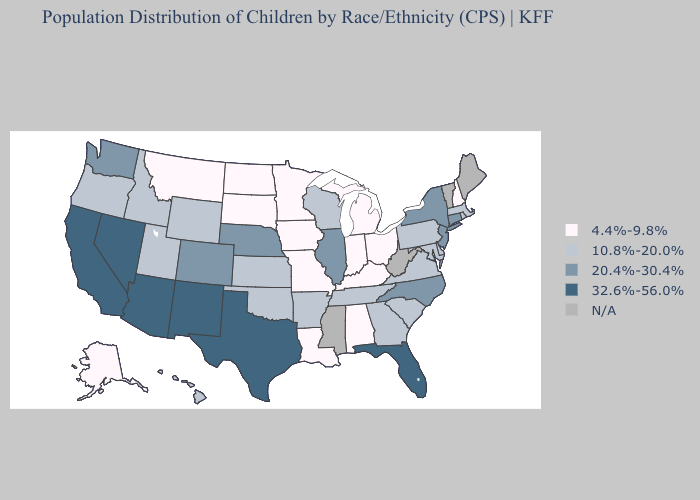What is the lowest value in the West?
Write a very short answer. 4.4%-9.8%. Does Arizona have the lowest value in the USA?
Give a very brief answer. No. Name the states that have a value in the range N/A?
Keep it brief. Maine, Mississippi, Vermont, West Virginia. Does the map have missing data?
Quick response, please. Yes. Does Hawaii have the lowest value in the USA?
Write a very short answer. No. Name the states that have a value in the range 20.4%-30.4%?
Give a very brief answer. Colorado, Connecticut, Illinois, Nebraska, New Jersey, New York, North Carolina, Washington. Among the states that border Maryland , which have the lowest value?
Short answer required. Delaware, Pennsylvania, Virginia. Name the states that have a value in the range 4.4%-9.8%?
Concise answer only. Alabama, Alaska, Indiana, Iowa, Kentucky, Louisiana, Michigan, Minnesota, Missouri, Montana, New Hampshire, North Dakota, Ohio, South Dakota. Which states hav the highest value in the Northeast?
Answer briefly. Connecticut, New Jersey, New York. Among the states that border West Virginia , does Kentucky have the lowest value?
Give a very brief answer. Yes. Does Colorado have the lowest value in the West?
Write a very short answer. No. Does Louisiana have the lowest value in the South?
Give a very brief answer. Yes. What is the value of Oregon?
Short answer required. 10.8%-20.0%. Among the states that border Vermont , which have the lowest value?
Be succinct. New Hampshire. What is the value of Nevada?
Write a very short answer. 32.6%-56.0%. 